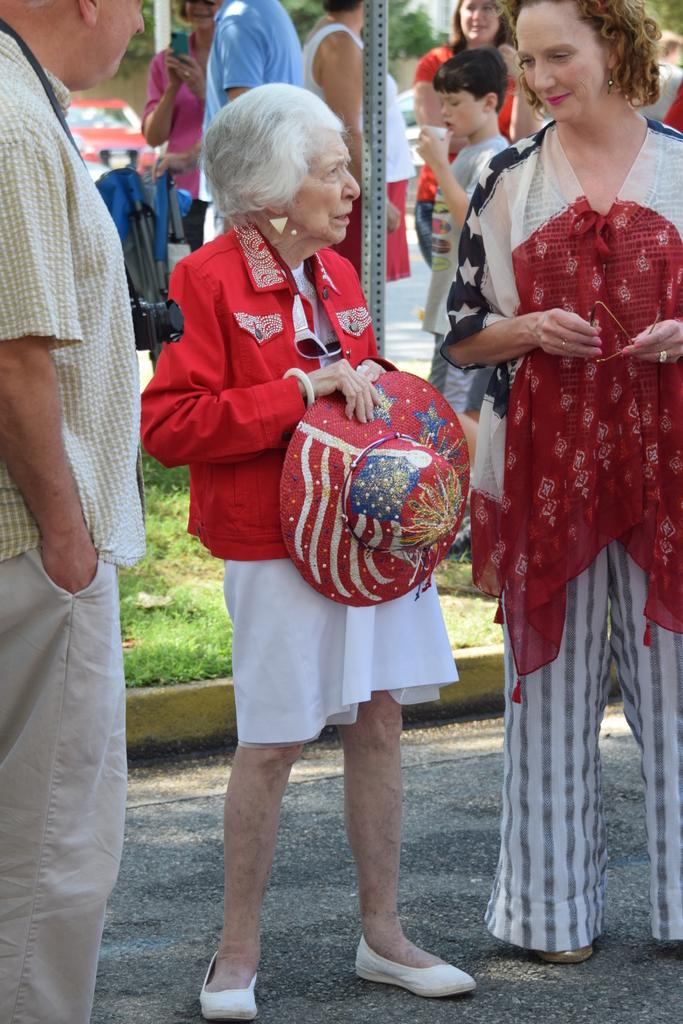How many people are in the image? There are people in the image, but the exact number is not specified. What type of surface is visible in the image? There is grass in the image. What type of object can be seen in the image? There is a vehicle in the image. What is the boy holding in the image? A boy is holding a cup in the image. What is the woman holding in the image? A woman is holding goggles in the image. What is one person holding in the image? One person is holding a hat in the image. What is another person holding in the image? Another person is holding a mobile in the image. What language is being spoken in the image? There is no information about the language being spoken in the image. How is the channel being distributed in the image? There is no mention of a channel or distribution in the image. 